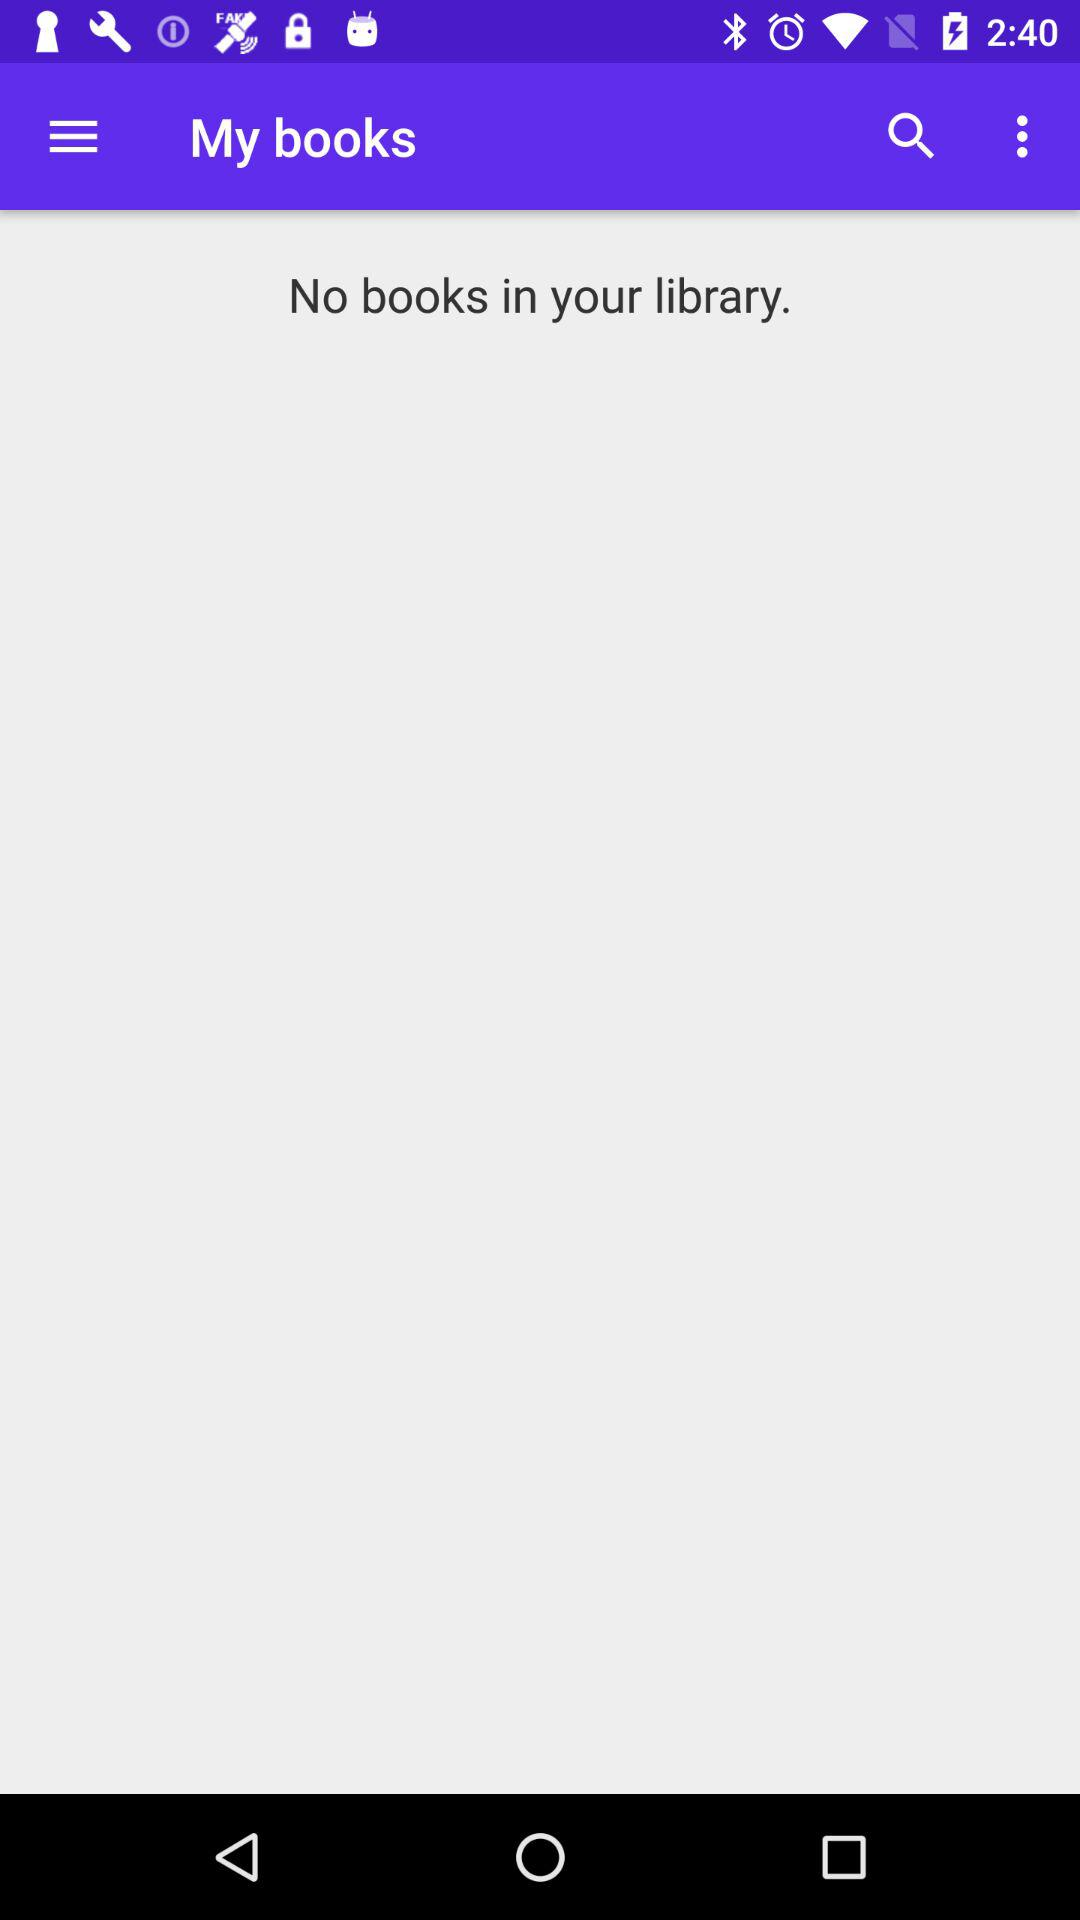How many books are in the library?
Answer the question using a single word or phrase. 0 